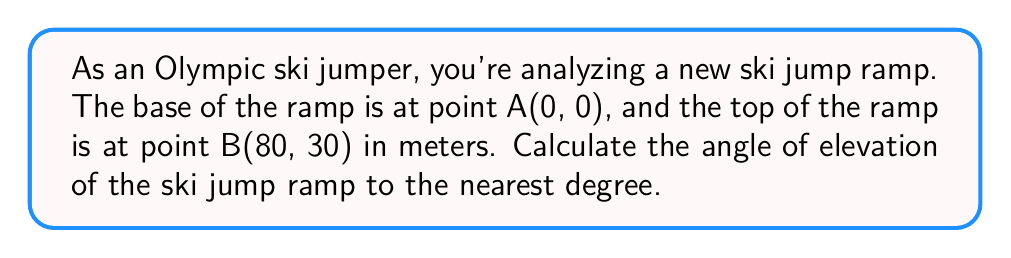Can you solve this math problem? To solve this problem, we'll use coordinate trigonometry. Let's break it down step-by-step:

1) We have two points:
   A(0, 0) - the base of the ramp
   B(80, 30) - the top of the ramp

2) To find the angle of elevation, we need to calculate the arctangent of the ratio of vertical change to horizontal change.

3) Vertical change (rise) = $y_2 - y_1 = 30 - 0 = 30$ meters

4) Horizontal change (run) = $x_2 - x_1 = 80 - 0 = 80$ meters

5) The angle of elevation, θ, is given by:

   $$\theta = \arctan(\frac{\text{rise}}{\text{run}})$$

6) Substituting our values:

   $$\theta = \arctan(\frac{30}{80})$$

7) Using a calculator or trigonometric tables:

   $$\theta \approx 20.556°$$

8) Rounding to the nearest degree:

   $$\theta \approx 21°$$

[asy]
import geometry;

size(200);
pair A = (0,0);
pair B = (80,30);
draw(A--B,arrow=Arrow(TeXHead));
draw(A--(80,0),dashed);
draw((80,0)--B,dashed);

label("A(0,0)", A, SW);
label("B(80,30)", B, NE);
label("80m", (40,0), S);
label("30m", (80,15), E);
label("θ", (10,5), NW);

dot(A);
dot(B);
[/asy]

This diagram illustrates the ski jump ramp with the given coordinates and the angle of elevation.
Answer: The angle of elevation of the ski jump ramp is approximately 21°. 